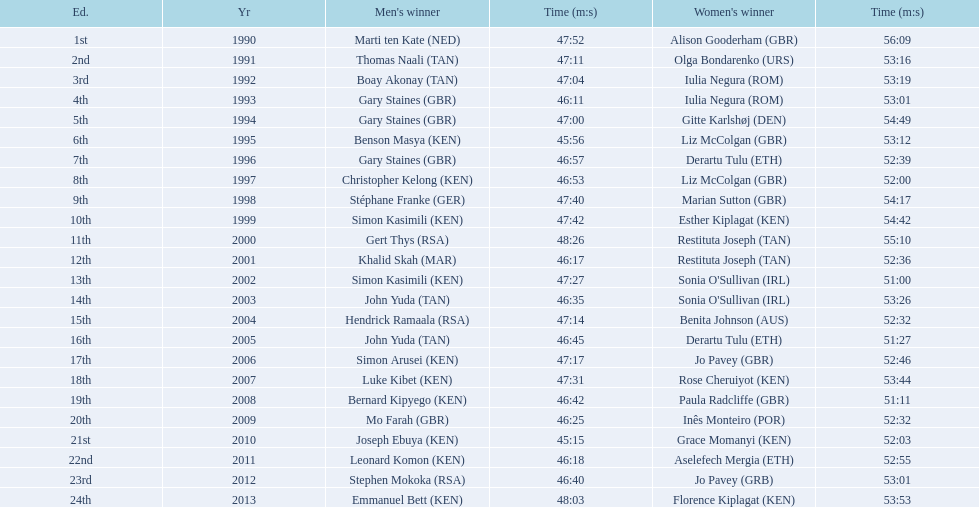What place did sonia o'sullivan finish in 2003? 14th. How long did it take her to finish? 53:26. 